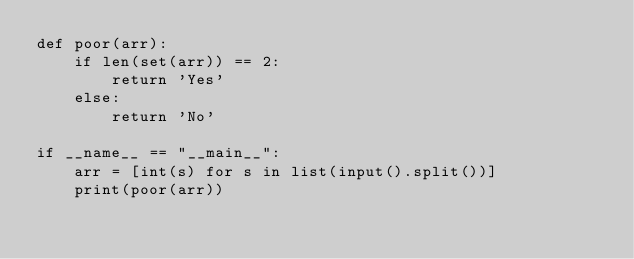<code> <loc_0><loc_0><loc_500><loc_500><_Python_>def poor(arr):
    if len(set(arr)) == 2:
        return 'Yes'
    else:
        return 'No'

if __name__ == "__main__":
    arr = [int(s) for s in list(input().split())]
    print(poor(arr))</code> 